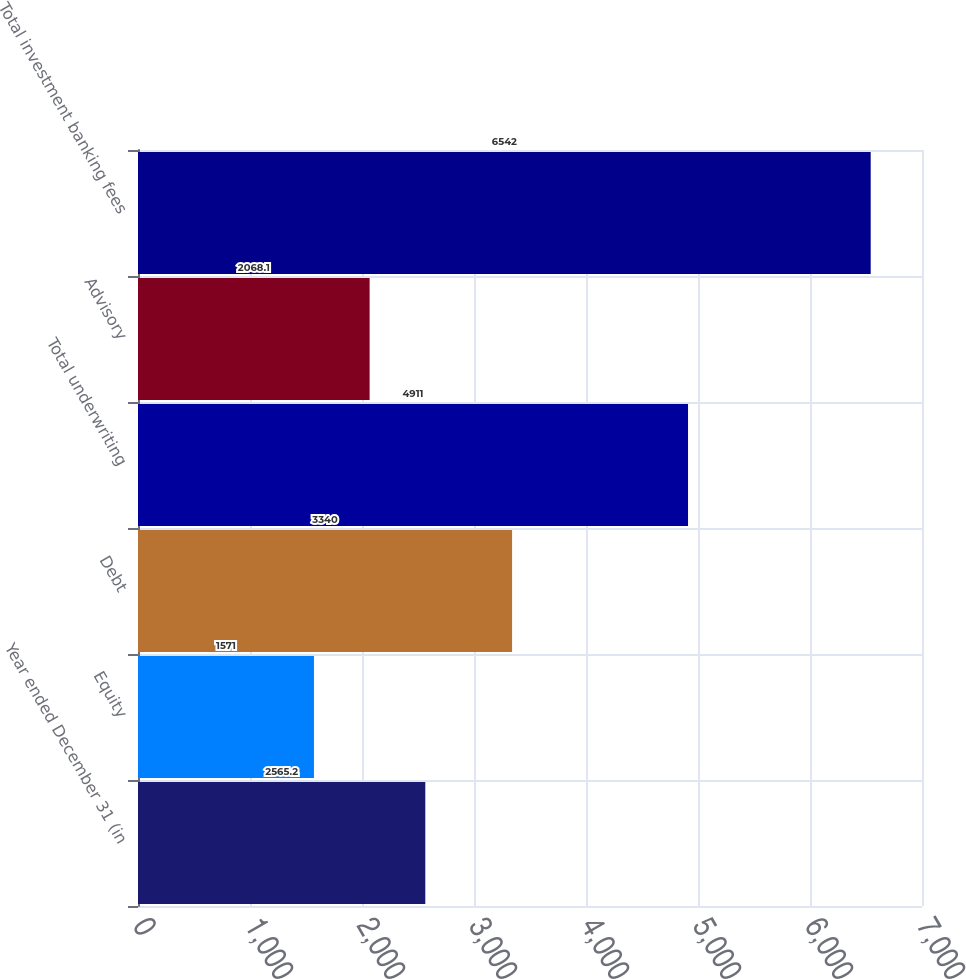Convert chart to OTSL. <chart><loc_0><loc_0><loc_500><loc_500><bar_chart><fcel>Year ended December 31 (in<fcel>Equity<fcel>Debt<fcel>Total underwriting<fcel>Advisory<fcel>Total investment banking fees<nl><fcel>2565.2<fcel>1571<fcel>3340<fcel>4911<fcel>2068.1<fcel>6542<nl></chart> 